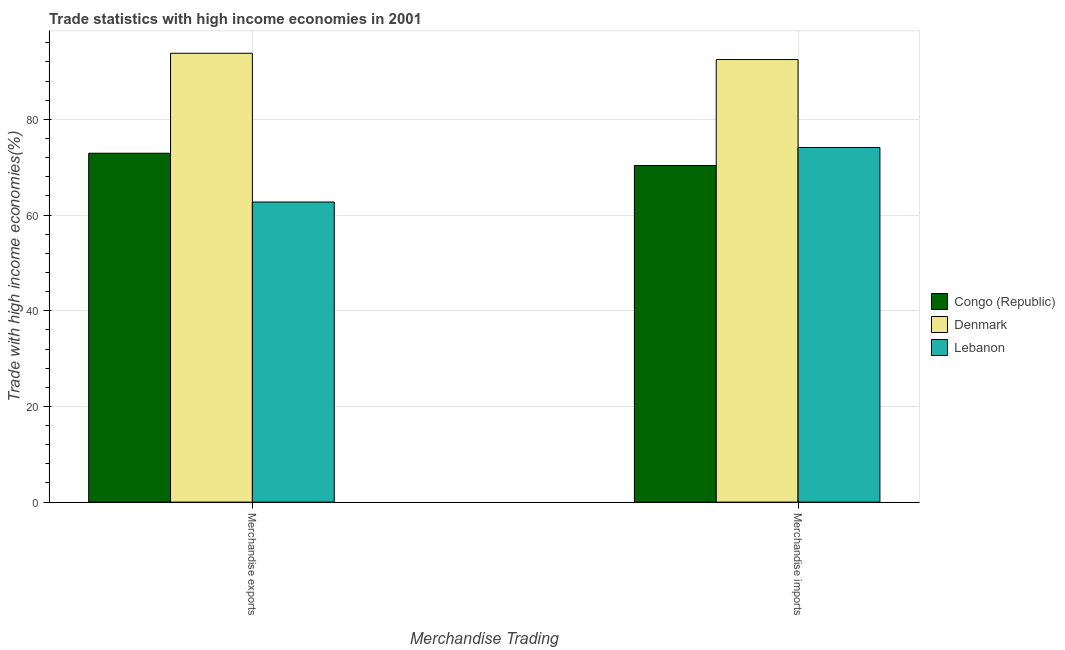How many groups of bars are there?
Offer a very short reply. 2. How many bars are there on the 2nd tick from the left?
Keep it short and to the point. 3. What is the label of the 1st group of bars from the left?
Give a very brief answer. Merchandise exports. What is the merchandise imports in Congo (Republic)?
Your answer should be very brief. 70.34. Across all countries, what is the maximum merchandise exports?
Provide a succinct answer. 93.8. Across all countries, what is the minimum merchandise exports?
Keep it short and to the point. 62.72. In which country was the merchandise imports minimum?
Your answer should be very brief. Congo (Republic). What is the total merchandise exports in the graph?
Offer a terse response. 229.43. What is the difference between the merchandise exports in Lebanon and that in Denmark?
Provide a succinct answer. -31.09. What is the difference between the merchandise exports in Congo (Republic) and the merchandise imports in Lebanon?
Make the answer very short. -1.2. What is the average merchandise exports per country?
Your response must be concise. 76.48. What is the difference between the merchandise imports and merchandise exports in Denmark?
Your answer should be very brief. -1.31. In how many countries, is the merchandise exports greater than 56 %?
Your answer should be compact. 3. What is the ratio of the merchandise imports in Denmark to that in Congo (Republic)?
Your answer should be very brief. 1.31. What does the 1st bar from the left in Merchandise imports represents?
Keep it short and to the point. Congo (Republic). What does the 2nd bar from the right in Merchandise imports represents?
Keep it short and to the point. Denmark. How many countries are there in the graph?
Provide a short and direct response. 3. Are the values on the major ticks of Y-axis written in scientific E-notation?
Offer a terse response. No. Where does the legend appear in the graph?
Ensure brevity in your answer.  Center right. What is the title of the graph?
Your answer should be compact. Trade statistics with high income economies in 2001. What is the label or title of the X-axis?
Provide a succinct answer. Merchandise Trading. What is the label or title of the Y-axis?
Your answer should be very brief. Trade with high income economies(%). What is the Trade with high income economies(%) in Congo (Republic) in Merchandise exports?
Keep it short and to the point. 72.91. What is the Trade with high income economies(%) of Denmark in Merchandise exports?
Provide a succinct answer. 93.8. What is the Trade with high income economies(%) of Lebanon in Merchandise exports?
Provide a short and direct response. 62.72. What is the Trade with high income economies(%) of Congo (Republic) in Merchandise imports?
Your answer should be compact. 70.34. What is the Trade with high income economies(%) in Denmark in Merchandise imports?
Provide a succinct answer. 92.49. What is the Trade with high income economies(%) in Lebanon in Merchandise imports?
Make the answer very short. 74.11. Across all Merchandise Trading, what is the maximum Trade with high income economies(%) of Congo (Republic)?
Provide a short and direct response. 72.91. Across all Merchandise Trading, what is the maximum Trade with high income economies(%) of Denmark?
Your answer should be compact. 93.8. Across all Merchandise Trading, what is the maximum Trade with high income economies(%) of Lebanon?
Offer a very short reply. 74.11. Across all Merchandise Trading, what is the minimum Trade with high income economies(%) in Congo (Republic)?
Make the answer very short. 70.34. Across all Merchandise Trading, what is the minimum Trade with high income economies(%) of Denmark?
Offer a very short reply. 92.49. Across all Merchandise Trading, what is the minimum Trade with high income economies(%) in Lebanon?
Give a very brief answer. 62.72. What is the total Trade with high income economies(%) in Congo (Republic) in the graph?
Your answer should be compact. 143.25. What is the total Trade with high income economies(%) in Denmark in the graph?
Provide a short and direct response. 186.29. What is the total Trade with high income economies(%) in Lebanon in the graph?
Your response must be concise. 136.83. What is the difference between the Trade with high income economies(%) in Congo (Republic) in Merchandise exports and that in Merchandise imports?
Your response must be concise. 2.57. What is the difference between the Trade with high income economies(%) of Denmark in Merchandise exports and that in Merchandise imports?
Make the answer very short. 1.31. What is the difference between the Trade with high income economies(%) in Lebanon in Merchandise exports and that in Merchandise imports?
Give a very brief answer. -11.4. What is the difference between the Trade with high income economies(%) in Congo (Republic) in Merchandise exports and the Trade with high income economies(%) in Denmark in Merchandise imports?
Provide a succinct answer. -19.58. What is the difference between the Trade with high income economies(%) in Congo (Republic) in Merchandise exports and the Trade with high income economies(%) in Lebanon in Merchandise imports?
Your answer should be compact. -1.2. What is the difference between the Trade with high income economies(%) in Denmark in Merchandise exports and the Trade with high income economies(%) in Lebanon in Merchandise imports?
Make the answer very short. 19.69. What is the average Trade with high income economies(%) of Congo (Republic) per Merchandise Trading?
Offer a very short reply. 71.63. What is the average Trade with high income economies(%) of Denmark per Merchandise Trading?
Make the answer very short. 93.15. What is the average Trade with high income economies(%) in Lebanon per Merchandise Trading?
Offer a very short reply. 68.41. What is the difference between the Trade with high income economies(%) in Congo (Republic) and Trade with high income economies(%) in Denmark in Merchandise exports?
Offer a very short reply. -20.89. What is the difference between the Trade with high income economies(%) of Congo (Republic) and Trade with high income economies(%) of Lebanon in Merchandise exports?
Your answer should be very brief. 10.2. What is the difference between the Trade with high income economies(%) in Denmark and Trade with high income economies(%) in Lebanon in Merchandise exports?
Ensure brevity in your answer.  31.09. What is the difference between the Trade with high income economies(%) of Congo (Republic) and Trade with high income economies(%) of Denmark in Merchandise imports?
Ensure brevity in your answer.  -22.15. What is the difference between the Trade with high income economies(%) of Congo (Republic) and Trade with high income economies(%) of Lebanon in Merchandise imports?
Make the answer very short. -3.77. What is the difference between the Trade with high income economies(%) in Denmark and Trade with high income economies(%) in Lebanon in Merchandise imports?
Your answer should be very brief. 18.38. What is the ratio of the Trade with high income economies(%) of Congo (Republic) in Merchandise exports to that in Merchandise imports?
Your response must be concise. 1.04. What is the ratio of the Trade with high income economies(%) in Denmark in Merchandise exports to that in Merchandise imports?
Keep it short and to the point. 1.01. What is the ratio of the Trade with high income economies(%) of Lebanon in Merchandise exports to that in Merchandise imports?
Your answer should be compact. 0.85. What is the difference between the highest and the second highest Trade with high income economies(%) of Congo (Republic)?
Your response must be concise. 2.57. What is the difference between the highest and the second highest Trade with high income economies(%) of Denmark?
Provide a succinct answer. 1.31. What is the difference between the highest and the second highest Trade with high income economies(%) in Lebanon?
Your answer should be very brief. 11.4. What is the difference between the highest and the lowest Trade with high income economies(%) of Congo (Republic)?
Your answer should be compact. 2.57. What is the difference between the highest and the lowest Trade with high income economies(%) in Denmark?
Your answer should be very brief. 1.31. What is the difference between the highest and the lowest Trade with high income economies(%) of Lebanon?
Offer a very short reply. 11.4. 